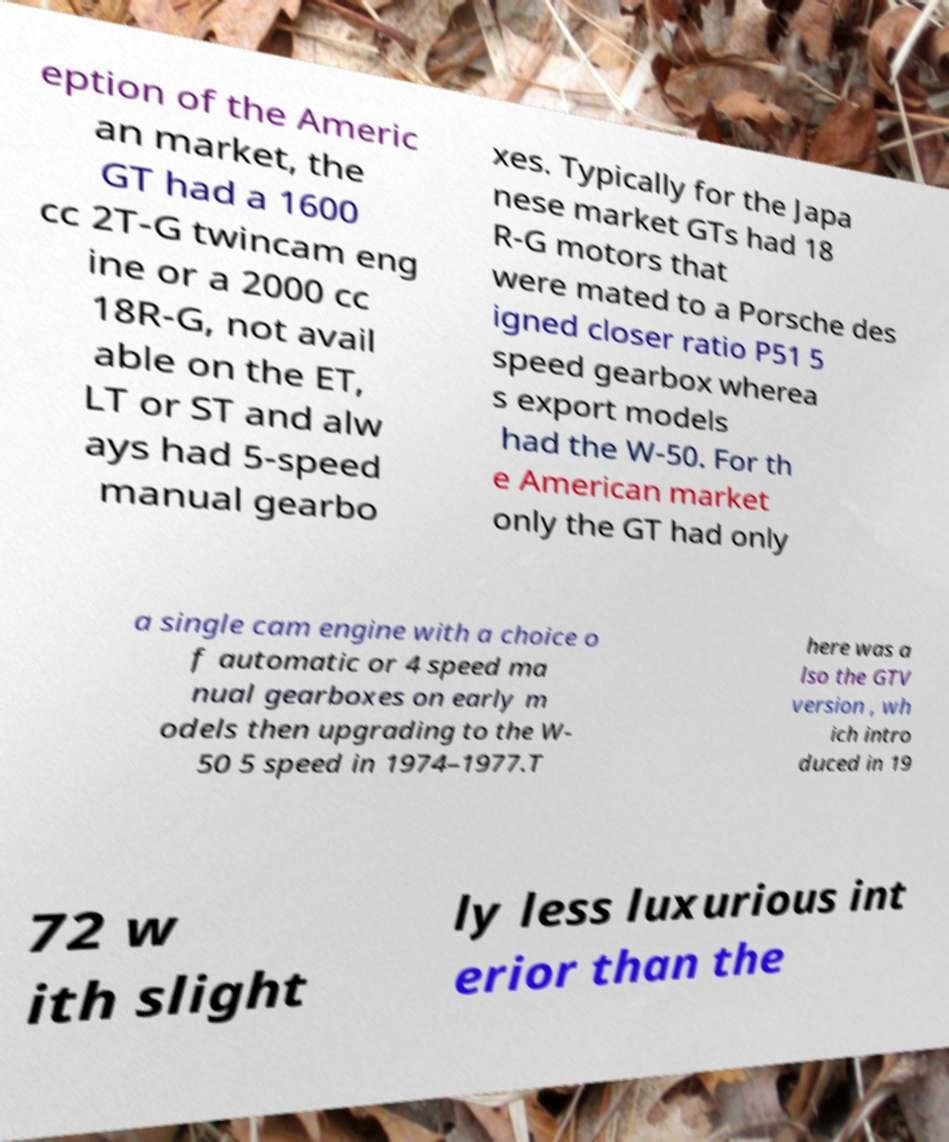Can you read and provide the text displayed in the image?This photo seems to have some interesting text. Can you extract and type it out for me? eption of the Americ an market, the GT had a 1600 cc 2T-G twincam eng ine or a 2000 cc 18R-G, not avail able on the ET, LT or ST and alw ays had 5-speed manual gearbo xes. Typically for the Japa nese market GTs had 18 R-G motors that were mated to a Porsche des igned closer ratio P51 5 speed gearbox wherea s export models had the W-50. For th e American market only the GT had only a single cam engine with a choice o f automatic or 4 speed ma nual gearboxes on early m odels then upgrading to the W- 50 5 speed in 1974–1977.T here was a lso the GTV version , wh ich intro duced in 19 72 w ith slight ly less luxurious int erior than the 